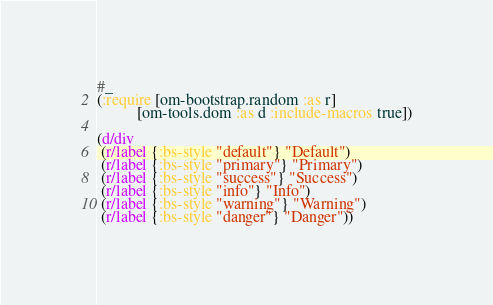Convert code to text. <code><loc_0><loc_0><loc_500><loc_500><_Clojure_>#_
(:require [om-bootstrap.random :as r]
          [om-tools.dom :as d :include-macros true])

(d/div
 (r/label {:bs-style "default"} "Default")
 (r/label {:bs-style "primary"} "Primary")
 (r/label {:bs-style "success"} "Success")
 (r/label {:bs-style "info"} "Info")
 (r/label {:bs-style "warning"} "Warning")
 (r/label {:bs-style "danger"} "Danger"))
</code> 